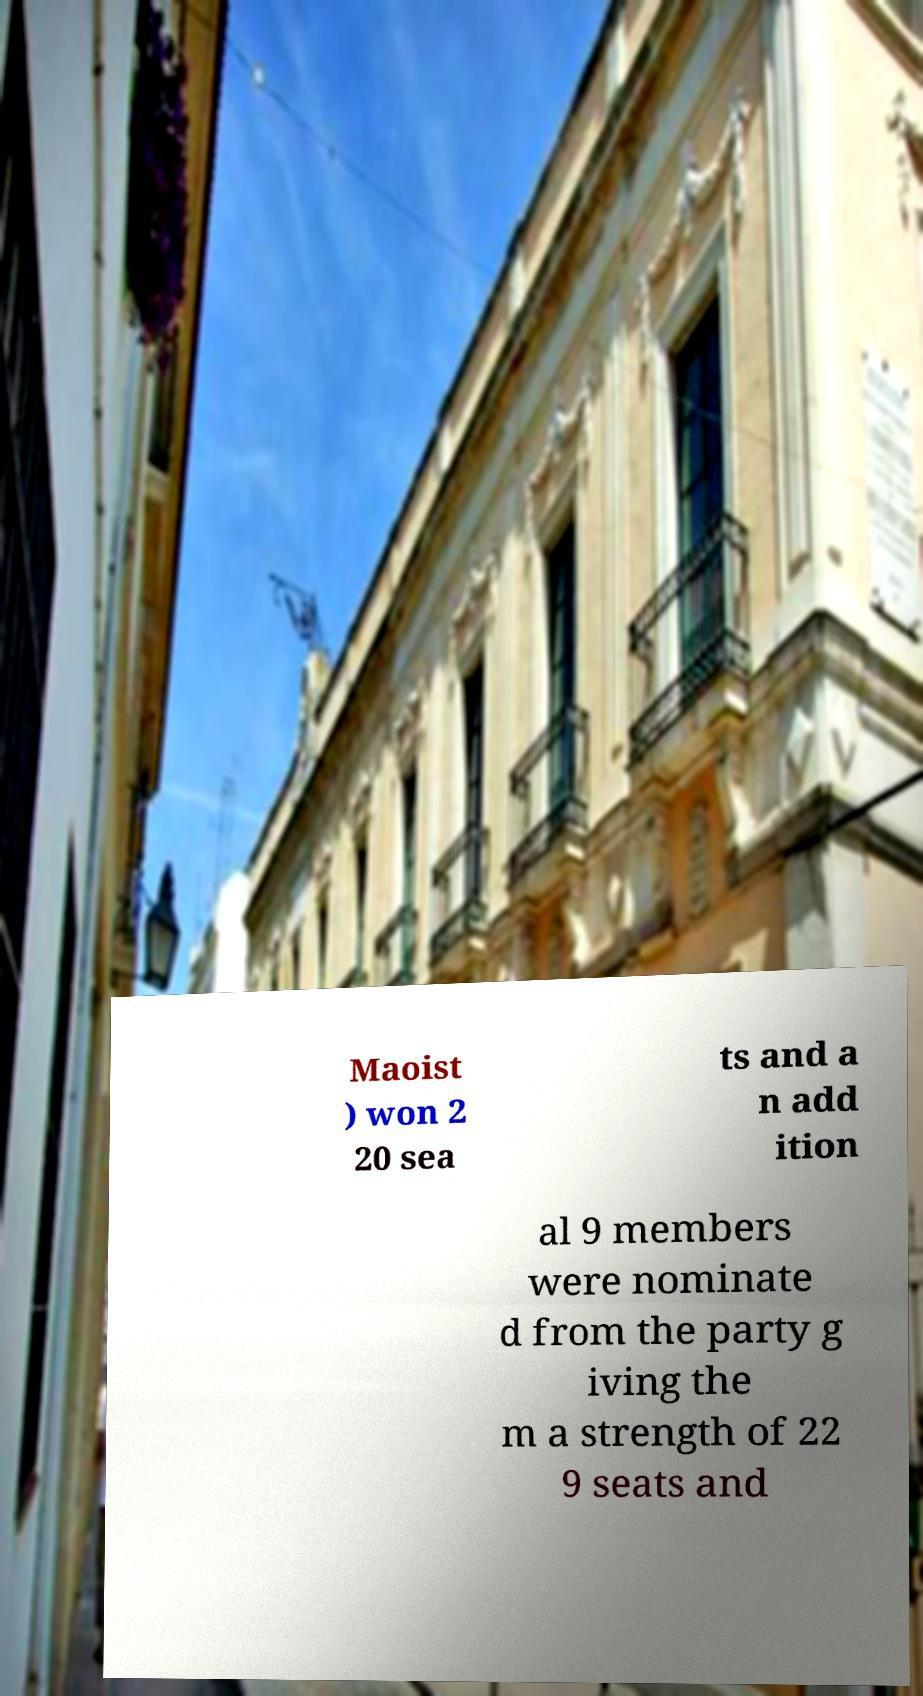Could you assist in decoding the text presented in this image and type it out clearly? Maoist ) won 2 20 sea ts and a n add ition al 9 members were nominate d from the party g iving the m a strength of 22 9 seats and 